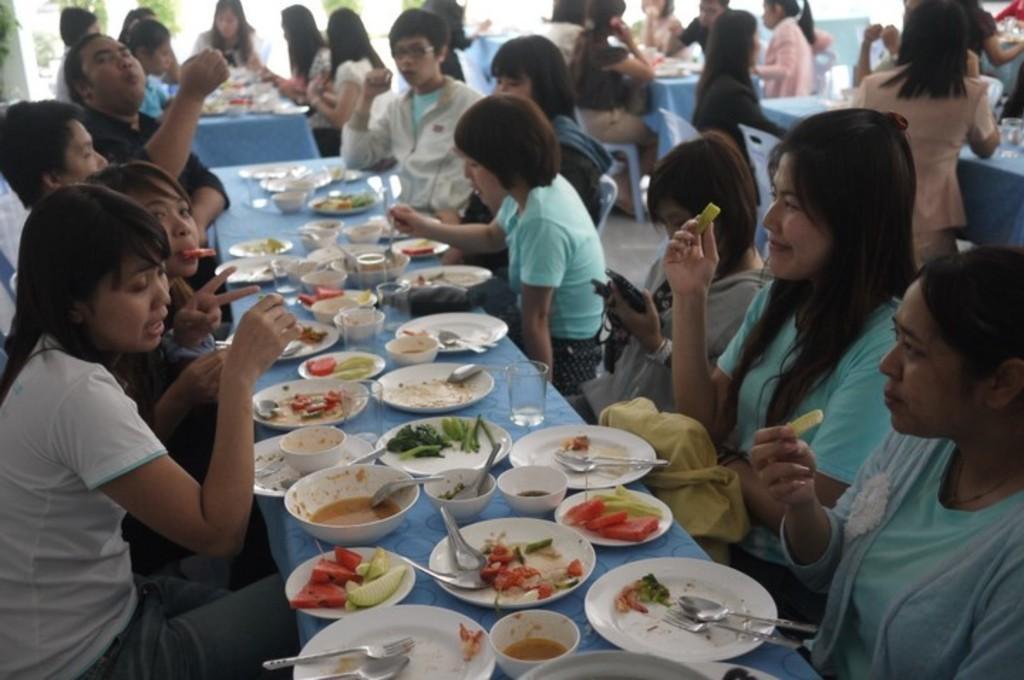Please provide a concise description of this image. In this image I can see a group of people sitting on chairs and wearing different color dresses. I can see few plates,spoons,food items,bowls and few objects on the table. 